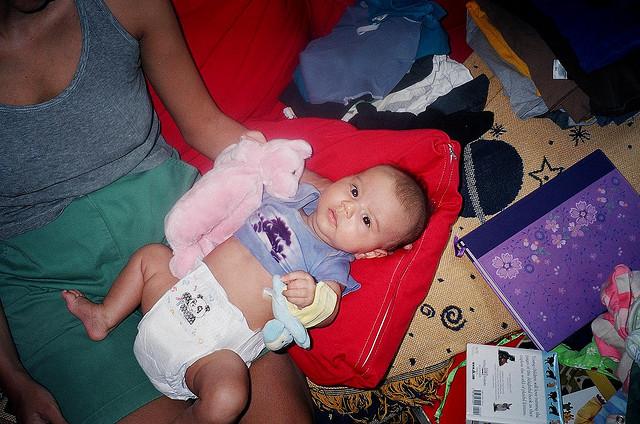What color is the book cover?
Be succinct. Purple. What is on the baby's wrist?
Short answer required. Toy. Is this a party?
Be succinct. No. How old is this baby?
Quick response, please. 1. Does this child have any hair?
Keep it brief. Yes. 